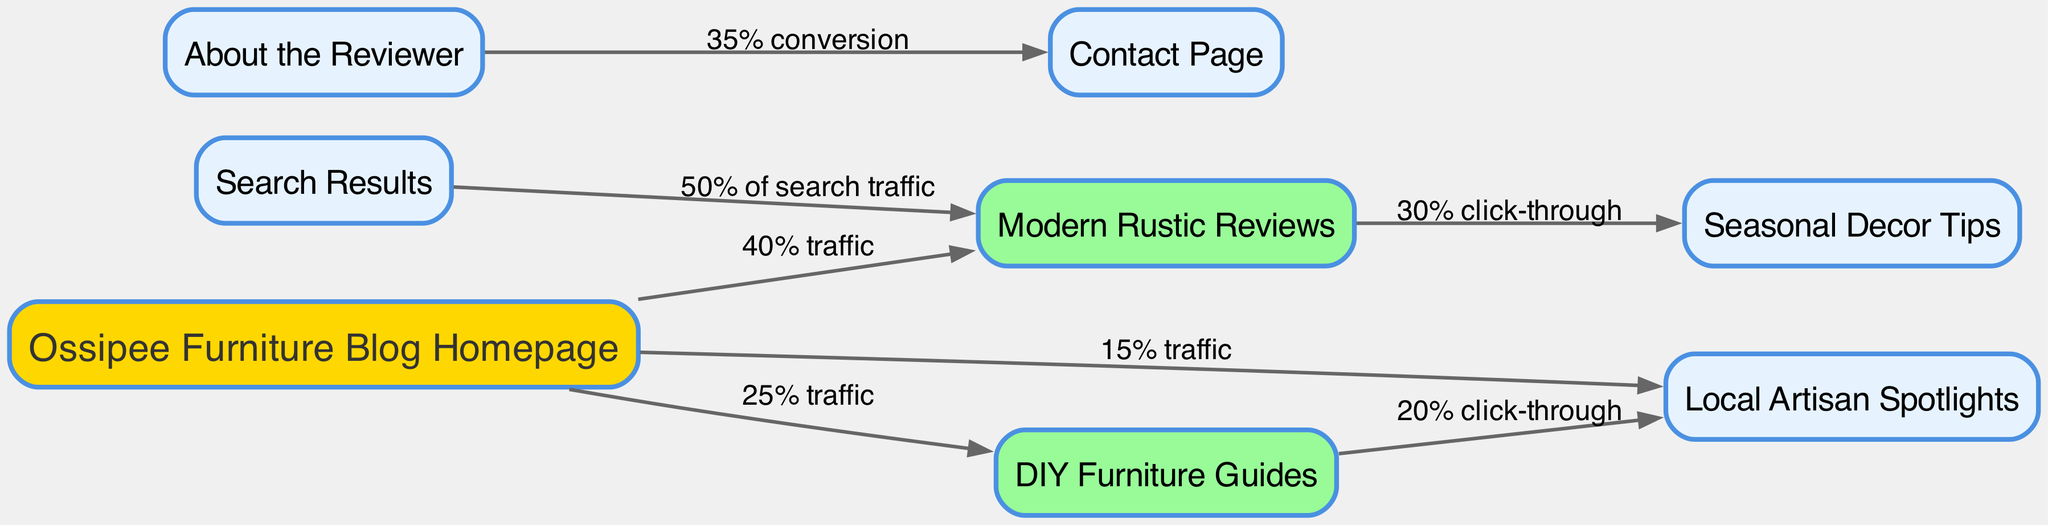What is the total number of nodes in the diagram? Counting the unique elements listed in the "nodes" section, there are eight distinct nodes presented: "Ossipee Furniture Blog Homepage", "Modern Rustic Reviews", "DIY Furniture Guides", "Local Artisan Spotlights", "Seasonal Decor Tips", "About the Reviewer", "Contact Page", and "Search Results".
Answer: 8 Which node receives the highest percentage of traffic? The highest percentage of traffic is directed to "Modern Rustic Reviews" from the "Ossipee Furniture Blog Homepage", with a value of 40%.
Answer: Modern Rustic Reviews What percentage of traffic goes from the homepage to DIY Furniture Guides? The connection from "Ossipee Furniture Blog Homepage" to "DIY Furniture Guides" has a traffic label of 25%.
Answer: 25% traffic How many edges are there in total in the diagram? By counting the edges listed in the "edges" section, we find there are seven unique connections made between nodes.
Answer: 7 What is the click-through rate from Modern Rustic Reviews to Seasonal Decor Tips? The edge from "Modern Rustic Reviews" to "Seasonal Decor Tips" shows a click-through rate of 30%.
Answer: 30% click-through Which node does the "About the Reviewer" lead to? Following the edge originating from "About the Reviewer", it points to the "Contact Page", indicating a direct relationship.
Answer: Contact Page What is the conversion rate from the About the Reviewer to the Contact Page? The edge from "About the Reviewer" to "Contact Page" indicates a conversion rate of 35%.
Answer: 35% conversion Which node has a traffic percentage connecting to Local Artisan Spotlights? The "Ossipee Furniture Blog Homepage" connects to "Local Artisan Spotlights" with a traffic label of 15%, and "DIY Furniture Guides" also connects with a click-through of 20%.
Answer: Ossipee Furniture Blog Homepage and DIY Furniture Guides What is the traffic percentage from the Search Results to Modern Rustic Reviews? The edge from "Search Results" leading to "Modern Rustic Reviews" shows that 50% of search traffic flows in that direction.
Answer: 50% of search traffic 